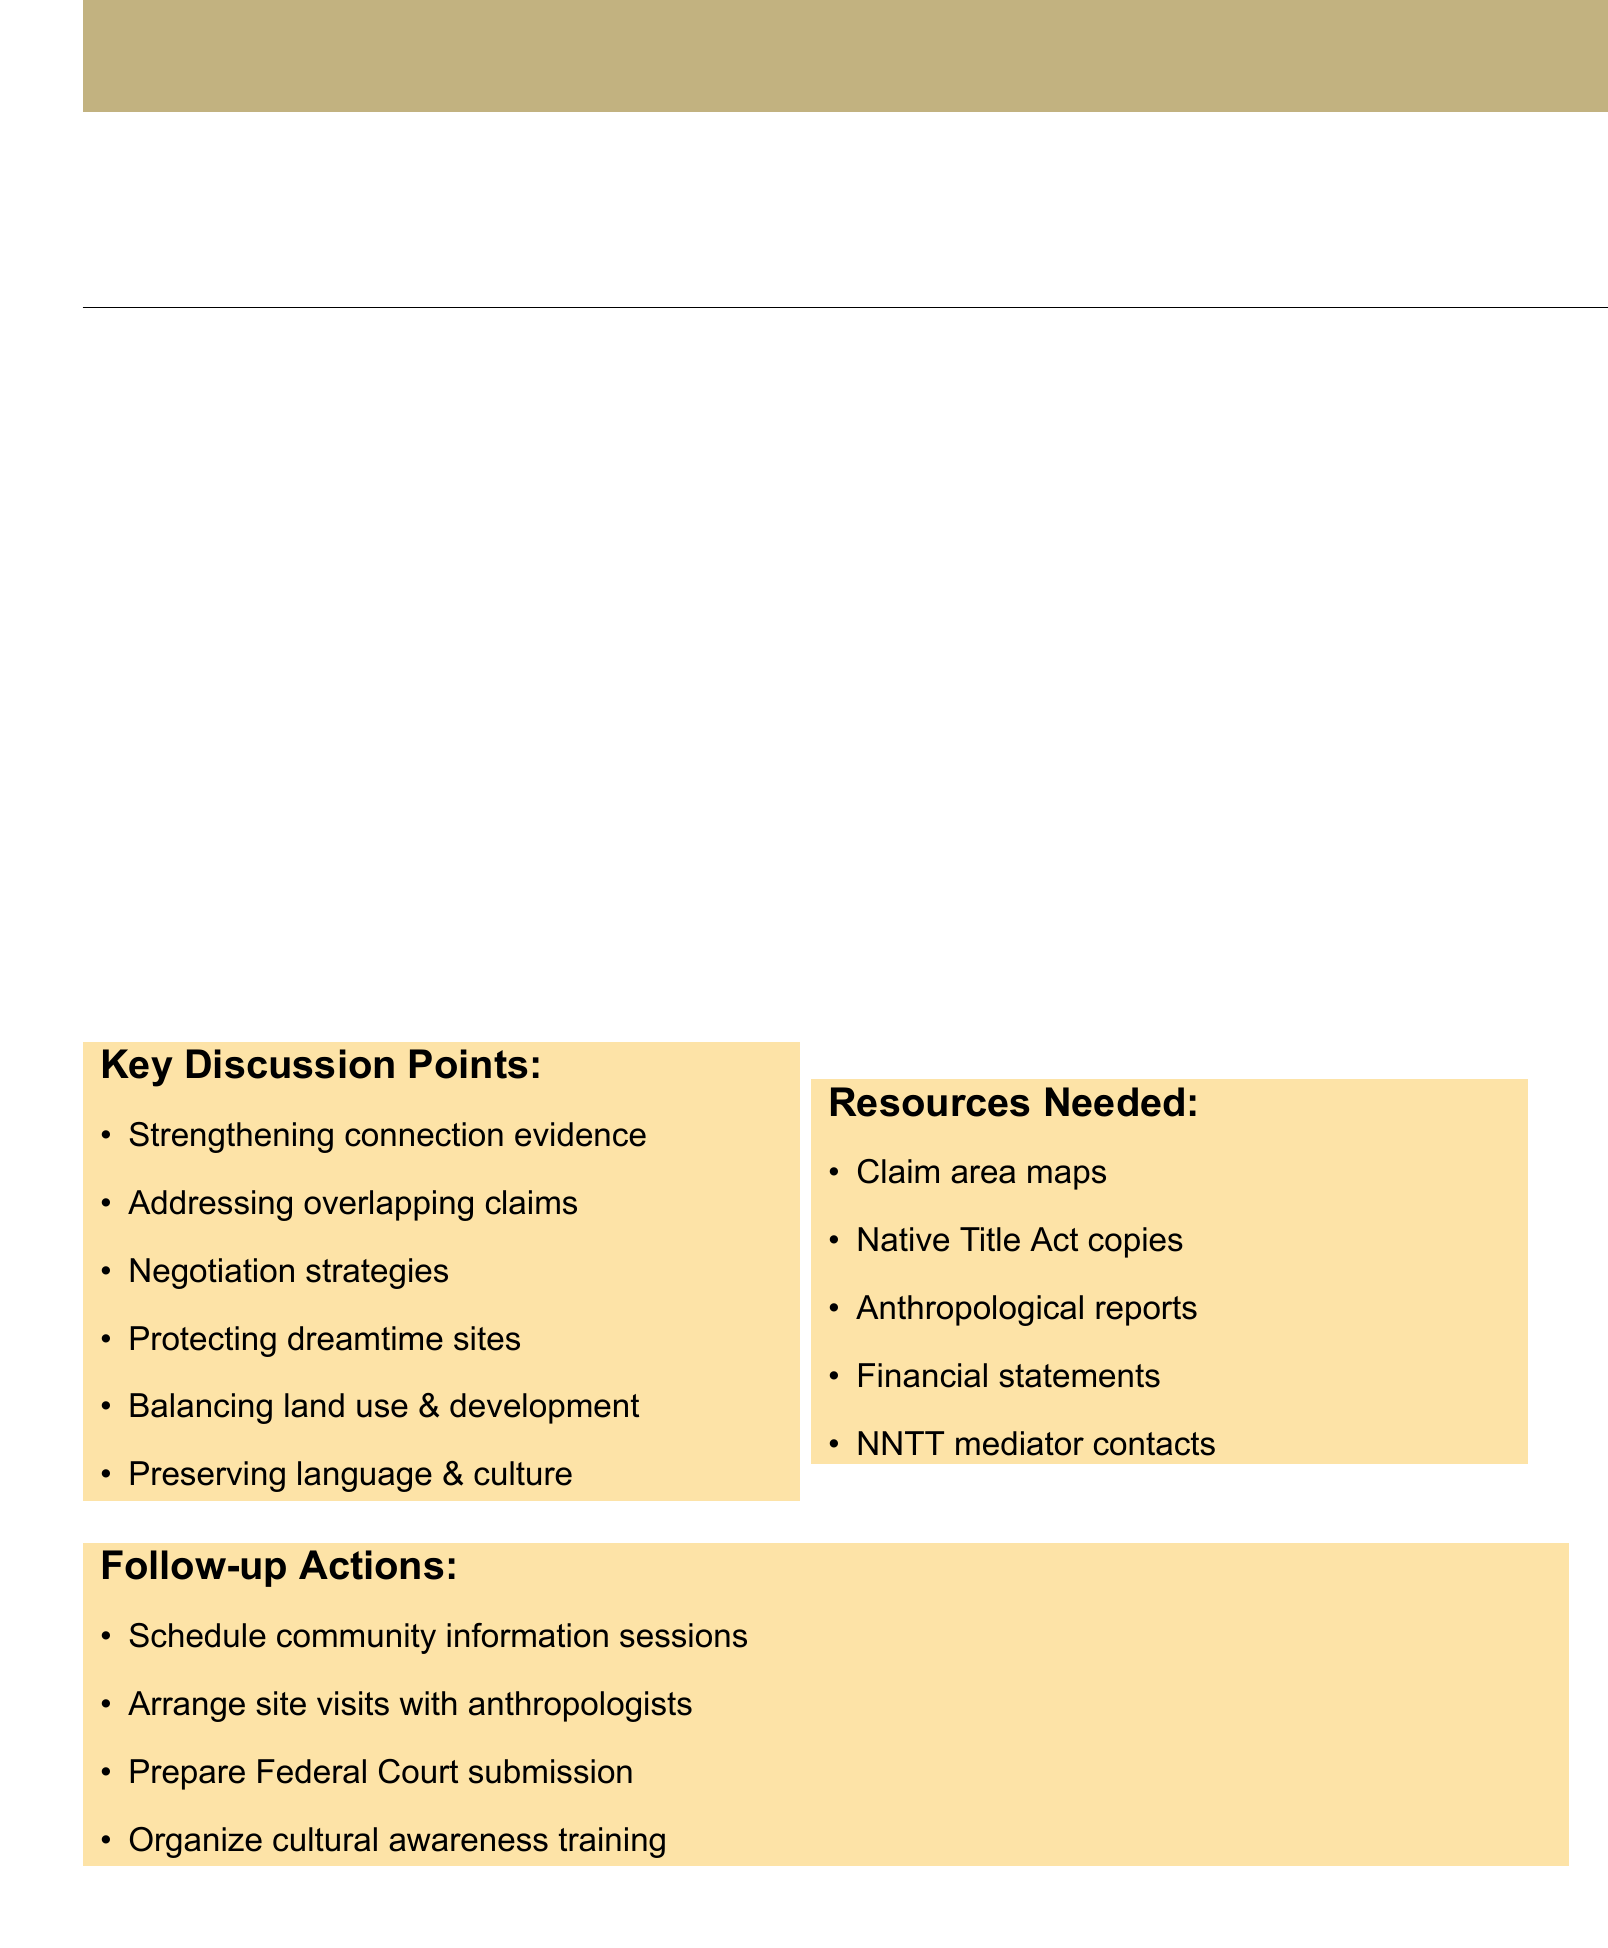What is the date of the meeting? The date of the meeting is specified in the document.
Answer: 15 September 2023 Who will provide the Welcome and Acknowledgement of Country? This information comes from the agenda item describing the welcome.
Answer: Elder Uncle Reg Dodd What is the duration of the discussion of key claim areas? The document lists the duration for each agenda item.
Answer: 45 minutes Which areas are focused on during the discussion of key claim areas? The agenda item specifies the areas of focus.
Answer: Simpson Desert Regional Reserve and Munga-Thirri National Park What is one key discussion point mentioned in the document? The document contains a list of key discussion points.
Answer: Strengthening evidence of continuous connection to country How long is allocated for negotiating tactics? The duration is provided in the agenda for this specific item.
Answer: 40 minutes What is one follow-up action that needs to be taken? The document lists several follow-up actions required.
Answer: Schedule community information sessions What resources are needed for the meeting? The document provides a list of resources required.
Answer: Maps of the claim area How many people are listed as attendees at the meeting? This information is found in the attendees section.
Answer: Four 